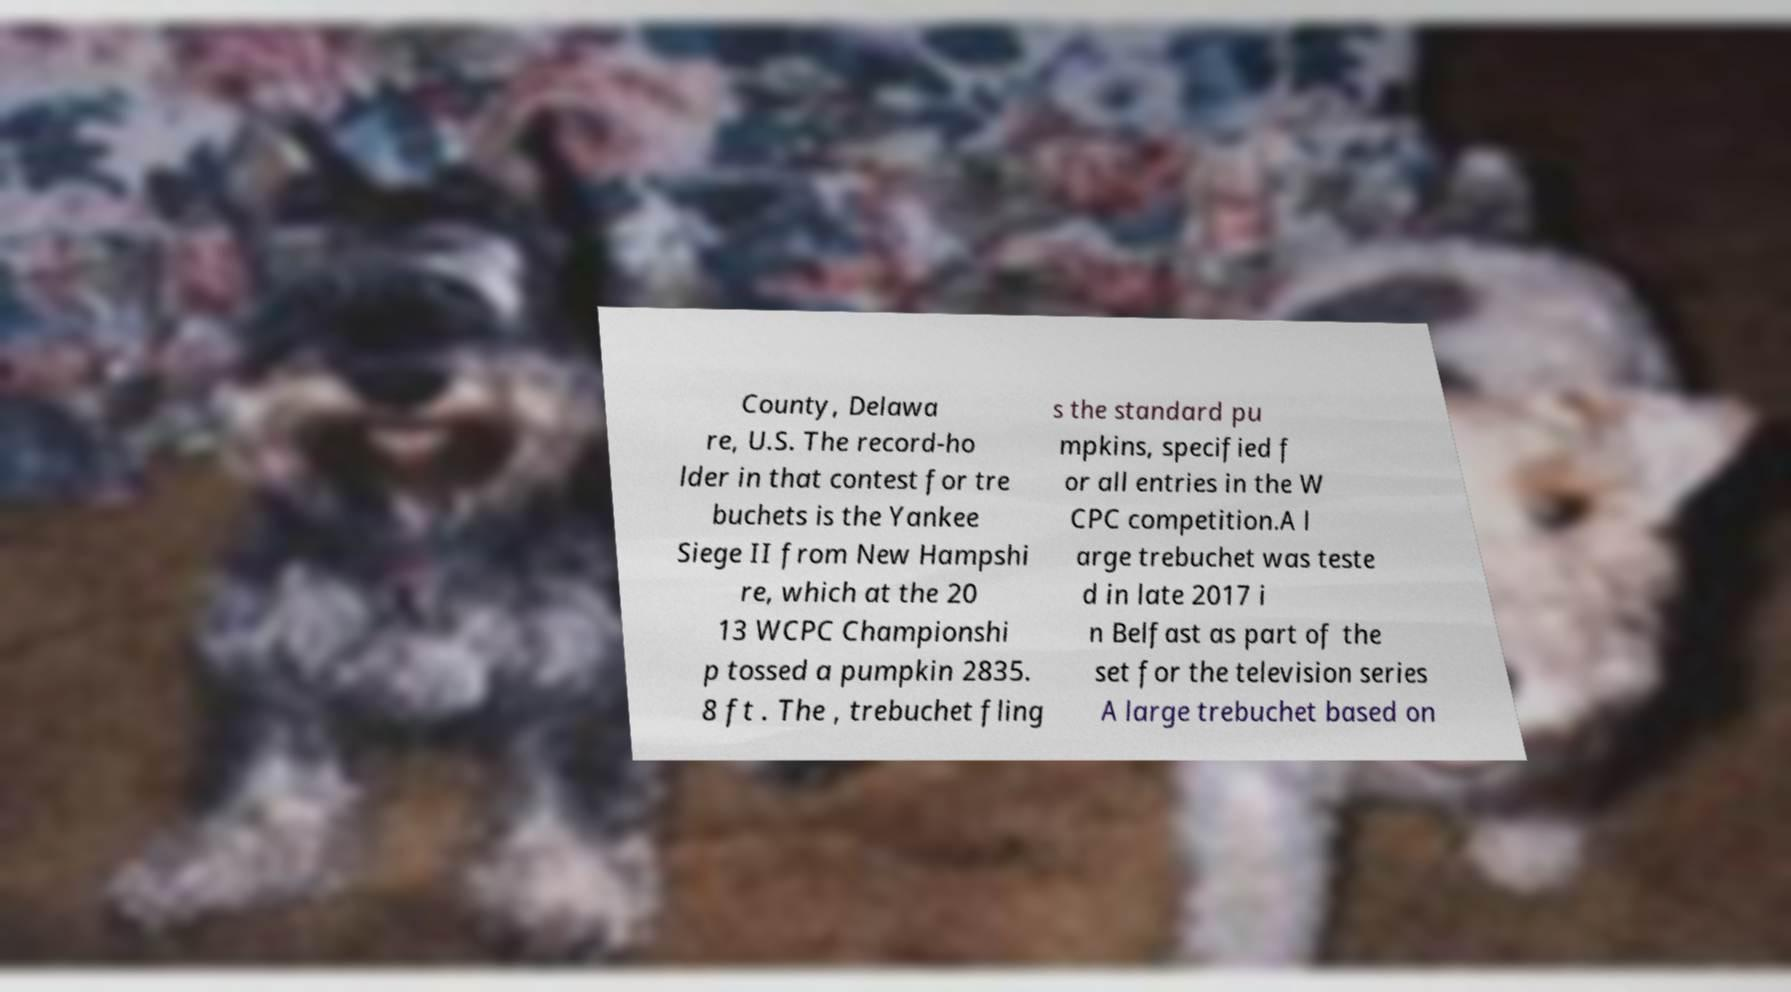I need the written content from this picture converted into text. Can you do that? County, Delawa re, U.S. The record-ho lder in that contest for tre buchets is the Yankee Siege II from New Hampshi re, which at the 20 13 WCPC Championshi p tossed a pumpkin 2835. 8 ft . The , trebuchet fling s the standard pu mpkins, specified f or all entries in the W CPC competition.A l arge trebuchet was teste d in late 2017 i n Belfast as part of the set for the television series A large trebuchet based on 